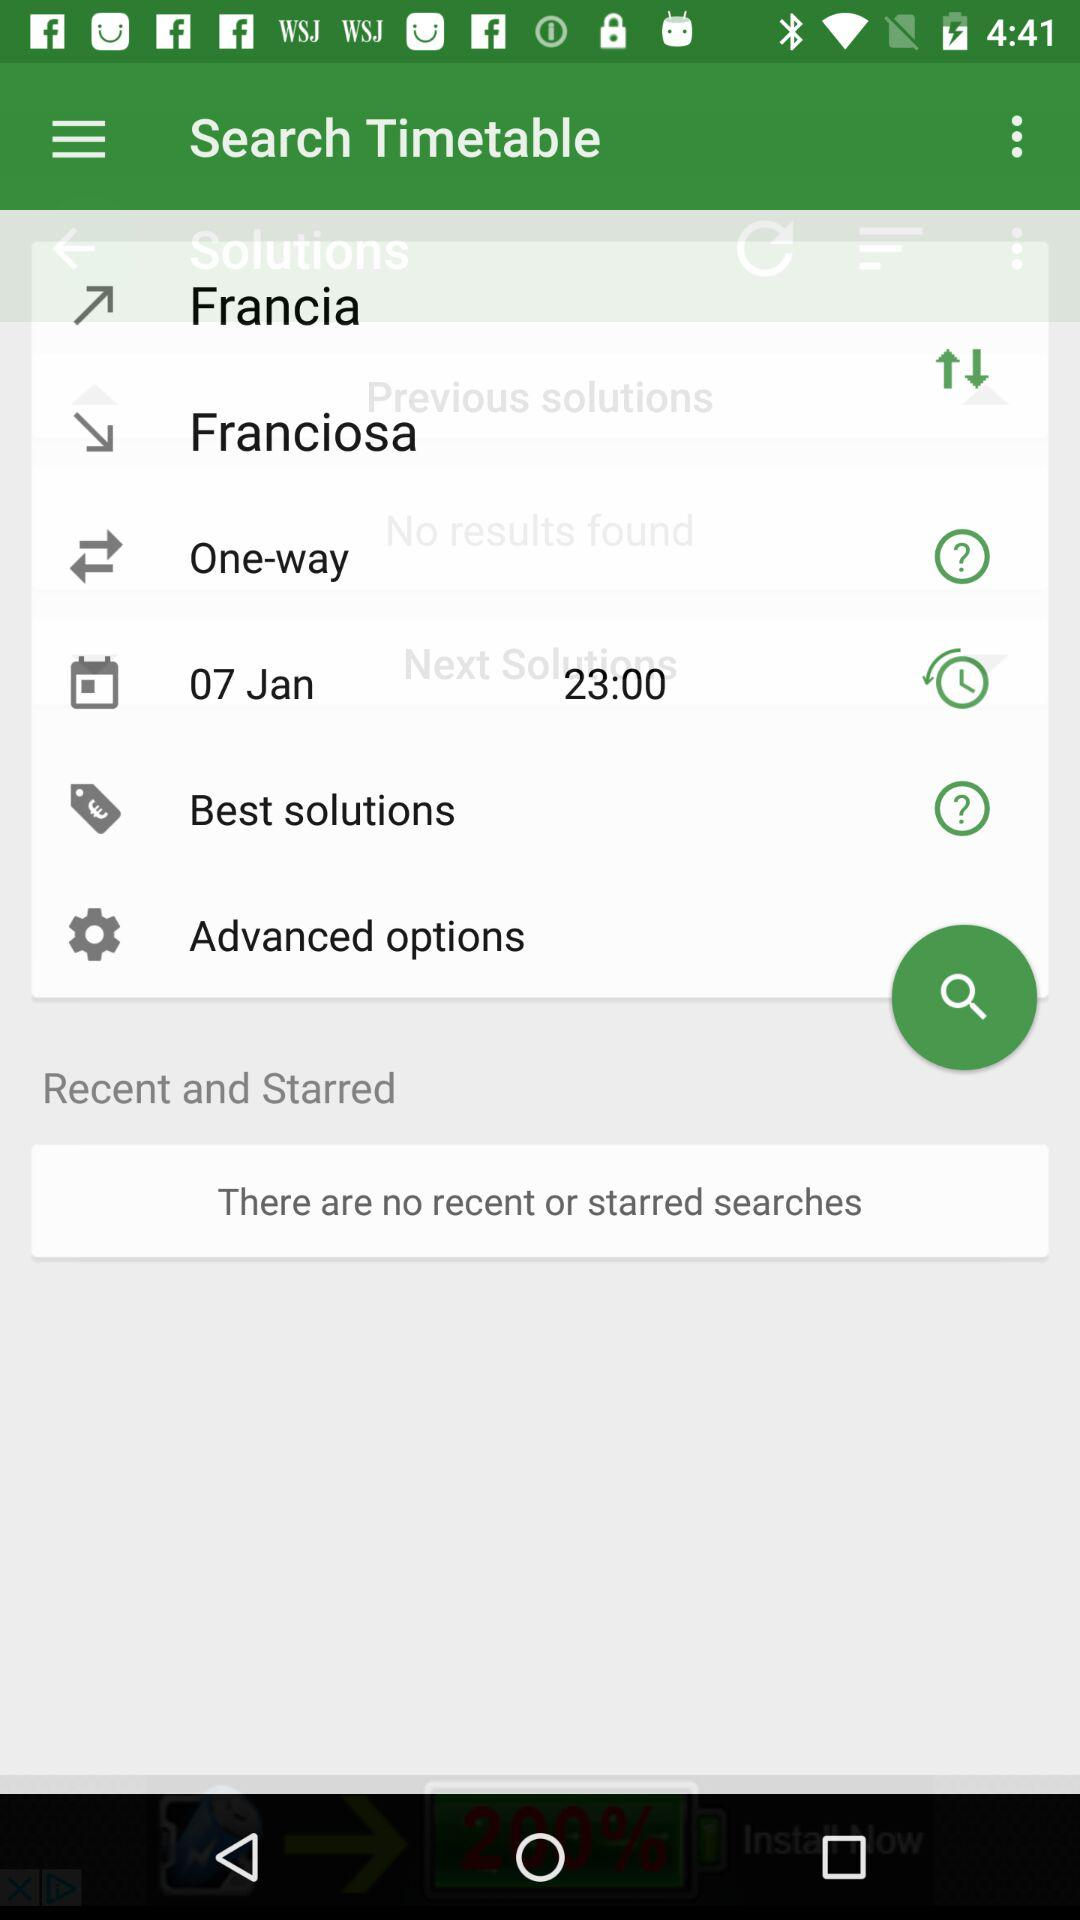How many notifications are there in "Advanced options"?
When the provided information is insufficient, respond with <no answer>. <no answer> 